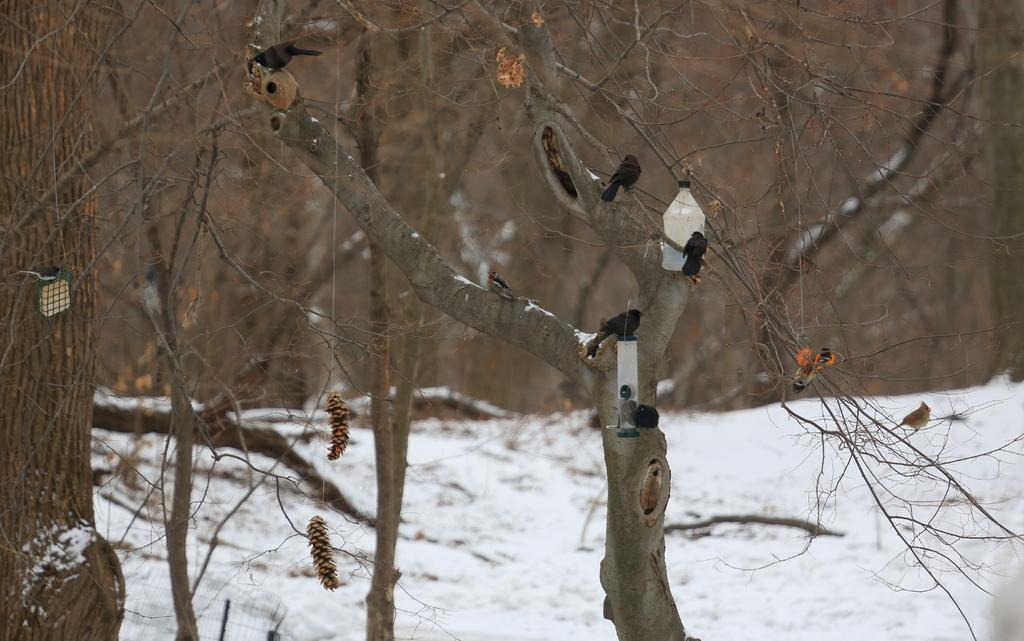What type of animals can be seen in the image? There are birds in the image. Where are the birds located in the image? The birds are sitting on a tree. What is the color of the birds? The birds are black in color. What is the condition of the trees in the image? There are dried trees in the image. What is the color of the snow in the image? The snow in the image is white in color. What type of harmony is being played by the birds in the image? There is no indication in the image that the birds are playing any type of harmony, as birds do not play musical instruments. 